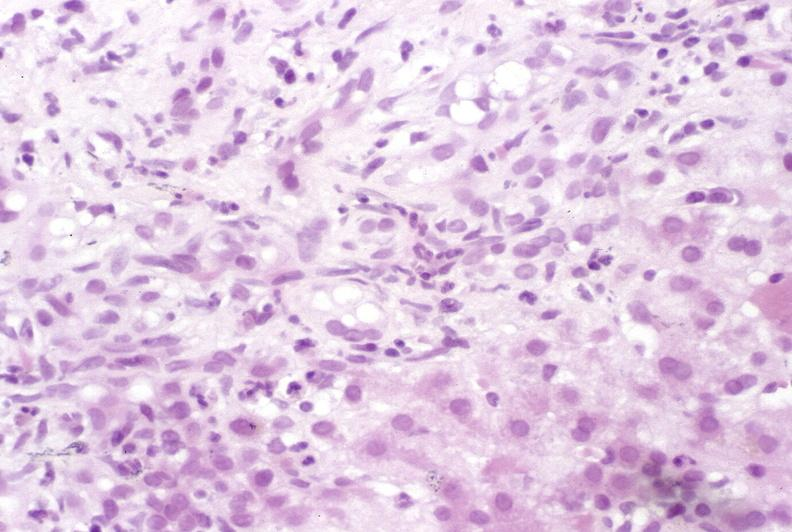what does this image show?
Answer the question using a single word or phrase. Primary sclerosing cholangitis 